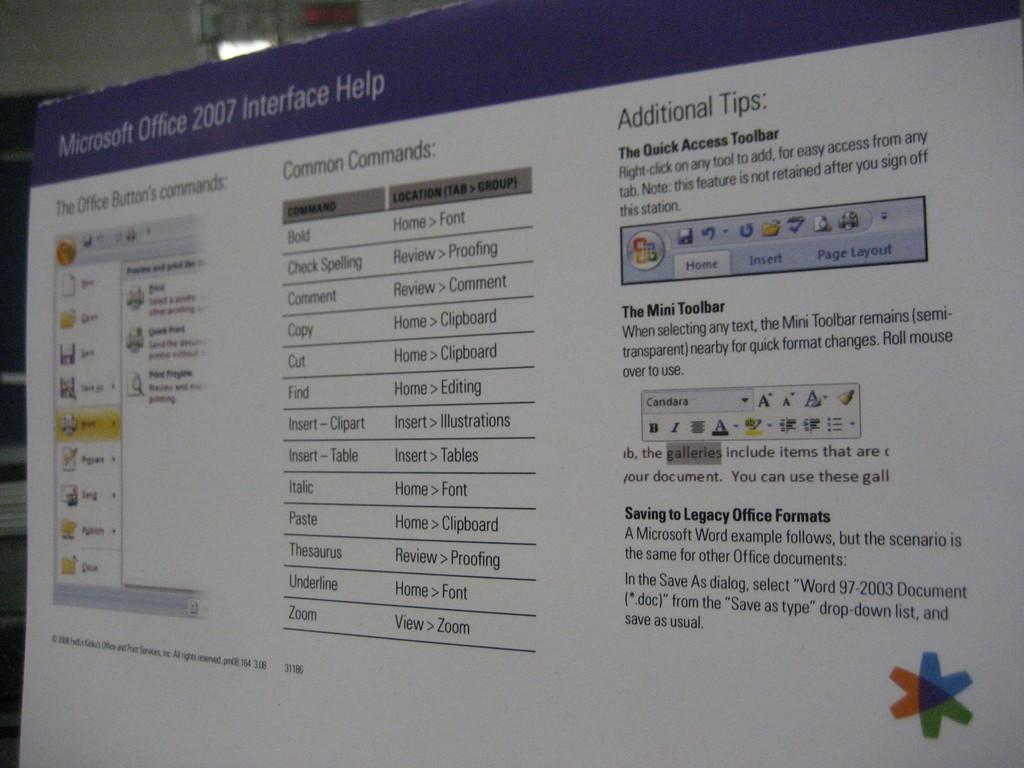<image>
Describe the image concisely. A screen which has Microsoft Office 2007 written on the top left. 